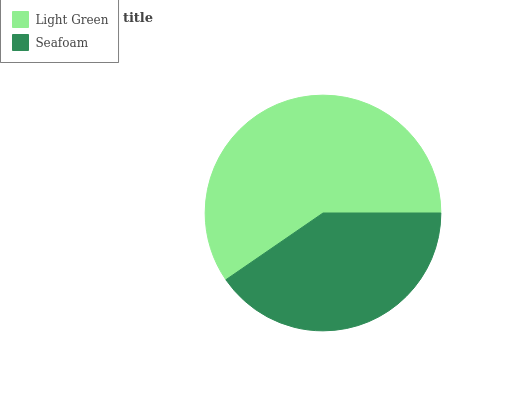Is Seafoam the minimum?
Answer yes or no. Yes. Is Light Green the maximum?
Answer yes or no. Yes. Is Seafoam the maximum?
Answer yes or no. No. Is Light Green greater than Seafoam?
Answer yes or no. Yes. Is Seafoam less than Light Green?
Answer yes or no. Yes. Is Seafoam greater than Light Green?
Answer yes or no. No. Is Light Green less than Seafoam?
Answer yes or no. No. Is Light Green the high median?
Answer yes or no. Yes. Is Seafoam the low median?
Answer yes or no. Yes. Is Seafoam the high median?
Answer yes or no. No. Is Light Green the low median?
Answer yes or no. No. 